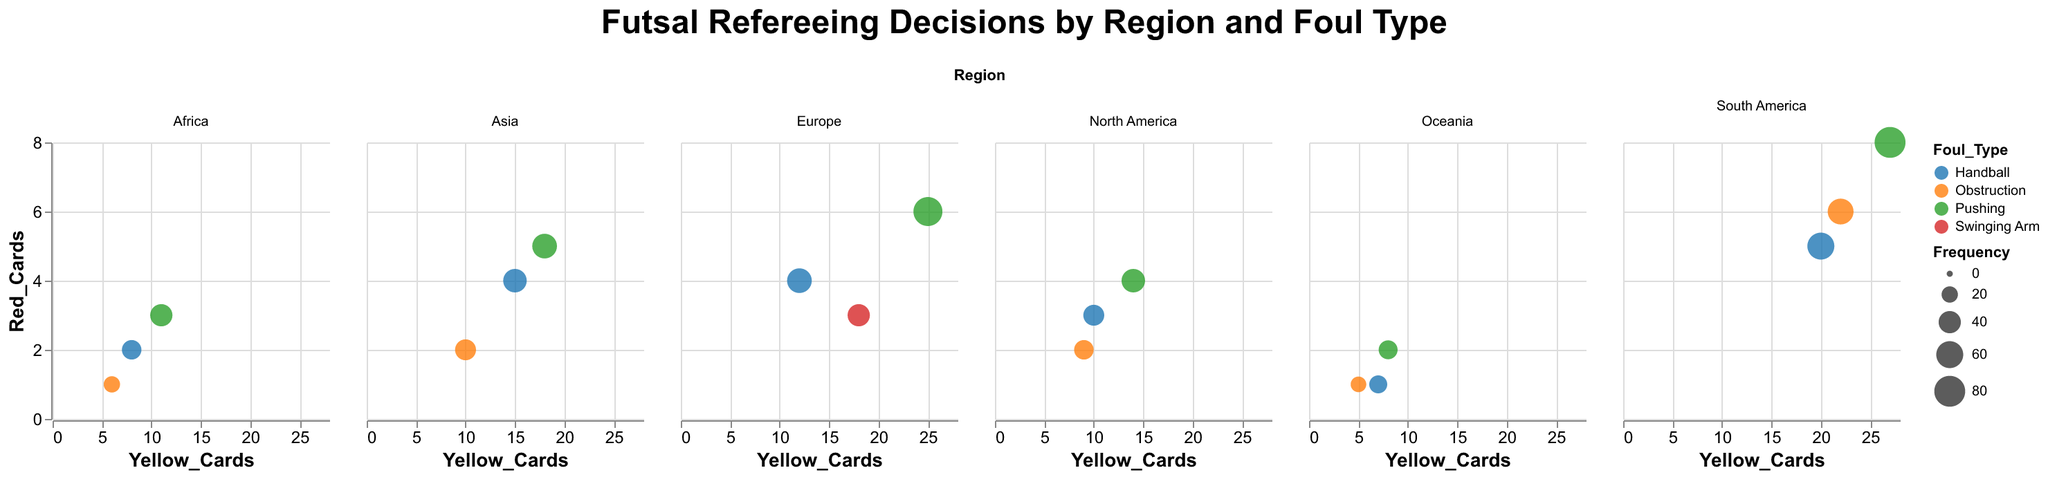What's the title of the figure? The title is displayed at the top of the figure. It clearly states the subject of the graphical content.
Answer: Futsal Refereeing Decisions by Region and Foul Type Which region has the highest frequency of "Pushing" fouls? By looking at the size of the bubbles representing "Pushing" across all regions, the largest bubble denotes the highest frequency.
Answer: South America What is the total number of yellow cards given for "Handball" in Asia? Locate the "Handball" bubble in the Asia subplot, and read the yellow card value associated with it.
Answer: 15 Comparing "Obstruction" in Asia and Oceania, which region has more penalties? Locate the "Obstruction" bubbles in the Asia and Oceania subplots and compare their penalty values.
Answer: Asia Which region issues the most red cards for "Pushing"? By finding and comparing the red card values for "Pushing" in each regional subplot, we identify the highest value.
Answer: South America For the Europe region, which foul type has the highest number of yellow cards? By examining the yellow card values for each foul type in the Europe subplot, we determine the foul type with the maximum number.
Answer: Pushing How does the frequency of "Handball" fouls in Africa compare to that in Europe? Check the sizes of the "Handball" bubbles in both the Africa and Europe subplots to compare their frequencies.
Answer: Europe has a higher frequency How many regions show "Handball" as having received more than 4 red cards? Identify "Handball" bubbles in each subplot and note those with red card values exceeding 4. Count these regions.
Answer: 4 regions (Europe, South America, Asia, North America) What's the average number of yellow cards given for "Pushing" in South America and North America? Sum the yellow cards given for "Pushing" in South America (27) and North America (14), then divide by the number of regions: (27+14)/2.
Answer: 20.5 Which foul type has the lowest overall frequency in Oceania? Compare the sizes of bubbles for different foul types in Oceania; the smallest bubble represents the lowest frequency.
Answer: Obstruction 